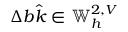<formula> <loc_0><loc_0><loc_500><loc_500>\Delta b \hat { k } \in \mathbb { W } _ { h } ^ { 2 , V }</formula> 